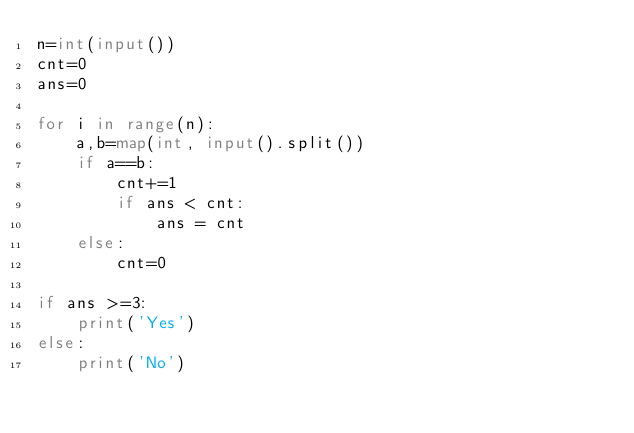<code> <loc_0><loc_0><loc_500><loc_500><_Python_>n=int(input()) 
cnt=0
ans=0

for i in range(n):
    a,b=map(int, input().split())
    if a==b:
        cnt+=1
        if ans < cnt:
            ans = cnt
    else:
        cnt=0

if ans >=3:
    print('Yes')
else:
    print('No')</code> 